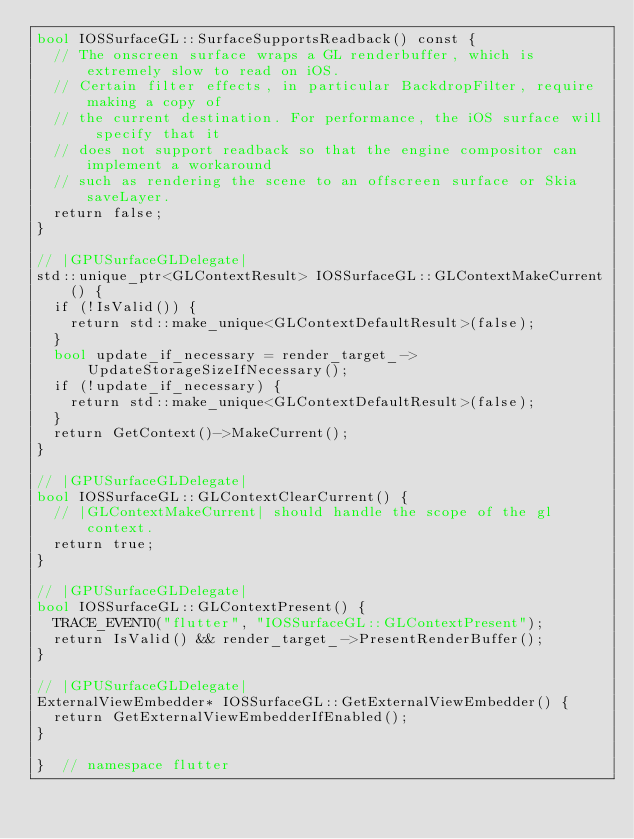Convert code to text. <code><loc_0><loc_0><loc_500><loc_500><_ObjectiveC_>bool IOSSurfaceGL::SurfaceSupportsReadback() const {
  // The onscreen surface wraps a GL renderbuffer, which is extremely slow to read on iOS.
  // Certain filter effects, in particular BackdropFilter, require making a copy of
  // the current destination. For performance, the iOS surface will specify that it
  // does not support readback so that the engine compositor can implement a workaround
  // such as rendering the scene to an offscreen surface or Skia saveLayer.
  return false;
}

// |GPUSurfaceGLDelegate|
std::unique_ptr<GLContextResult> IOSSurfaceGL::GLContextMakeCurrent() {
  if (!IsValid()) {
    return std::make_unique<GLContextDefaultResult>(false);
  }
  bool update_if_necessary = render_target_->UpdateStorageSizeIfNecessary();
  if (!update_if_necessary) {
    return std::make_unique<GLContextDefaultResult>(false);
  }
  return GetContext()->MakeCurrent();
}

// |GPUSurfaceGLDelegate|
bool IOSSurfaceGL::GLContextClearCurrent() {
  // |GLContextMakeCurrent| should handle the scope of the gl context.
  return true;
}

// |GPUSurfaceGLDelegate|
bool IOSSurfaceGL::GLContextPresent() {
  TRACE_EVENT0("flutter", "IOSSurfaceGL::GLContextPresent");
  return IsValid() && render_target_->PresentRenderBuffer();
}

// |GPUSurfaceGLDelegate|
ExternalViewEmbedder* IOSSurfaceGL::GetExternalViewEmbedder() {
  return GetExternalViewEmbedderIfEnabled();
}

}  // namespace flutter
</code> 